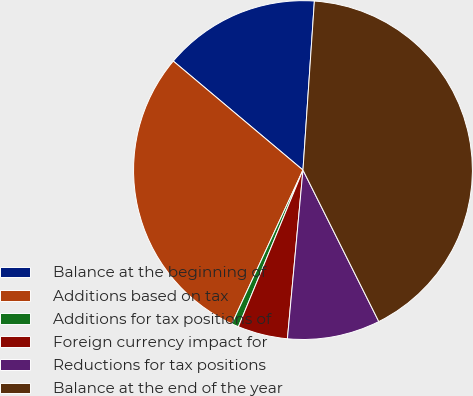Convert chart. <chart><loc_0><loc_0><loc_500><loc_500><pie_chart><fcel>Balance at the beginning of<fcel>Additions based on tax<fcel>Additions for tax positions of<fcel>Foreign currency impact for<fcel>Reductions for tax positions<fcel>Balance at the end of the year<nl><fcel>14.95%<fcel>29.23%<fcel>0.67%<fcel>4.76%<fcel>8.85%<fcel>41.54%<nl></chart> 